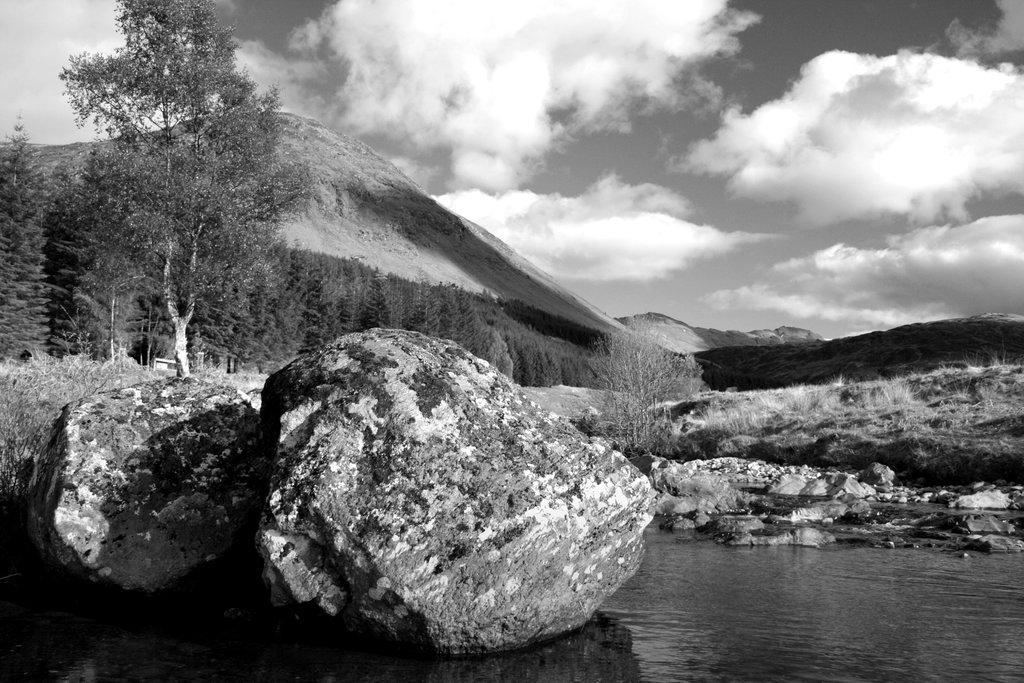How would you summarize this image in a sentence or two? In this image I can see few rocks, water, trees, mountains and sky, and the image is in black and white. 